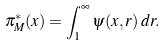Convert formula to latex. <formula><loc_0><loc_0><loc_500><loc_500>\pi ^ { * } _ { M } ( x ) = \int _ { 1 } ^ { \infty } \psi ( x , r ) \, d r .</formula> 